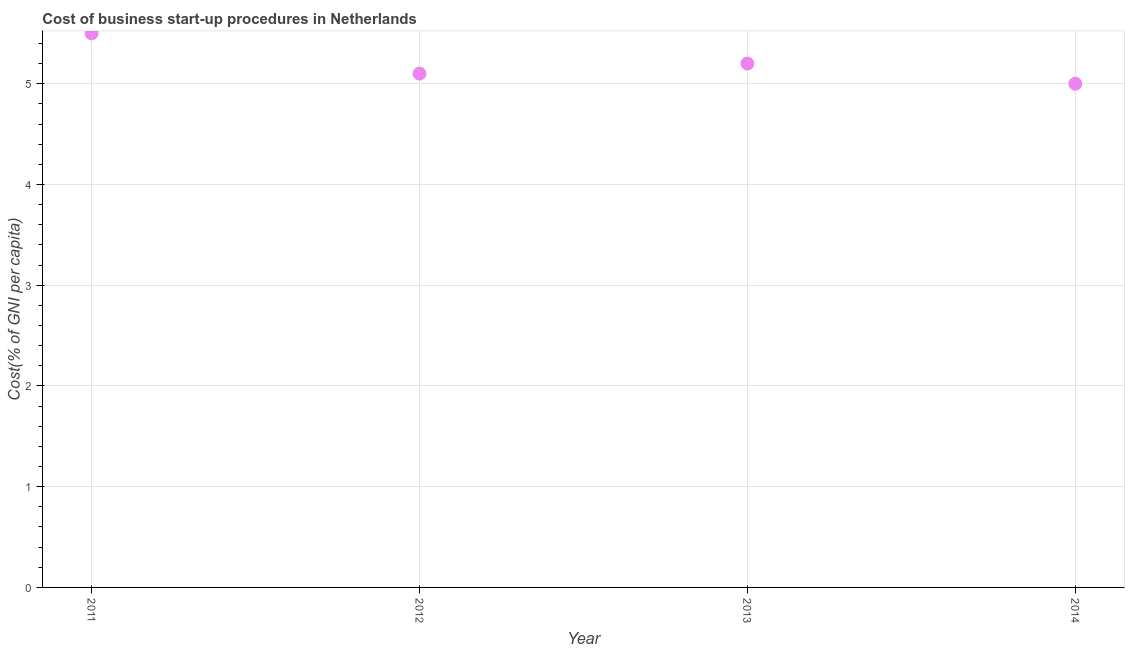What is the cost of business startup procedures in 2014?
Make the answer very short. 5. Across all years, what is the maximum cost of business startup procedures?
Offer a terse response. 5.5. Across all years, what is the minimum cost of business startup procedures?
Provide a succinct answer. 5. In which year was the cost of business startup procedures maximum?
Keep it short and to the point. 2011. In which year was the cost of business startup procedures minimum?
Offer a very short reply. 2014. What is the sum of the cost of business startup procedures?
Your answer should be compact. 20.8. What is the difference between the cost of business startup procedures in 2012 and 2013?
Give a very brief answer. -0.1. What is the median cost of business startup procedures?
Make the answer very short. 5.15. In how many years, is the cost of business startup procedures greater than 3.4 %?
Your answer should be compact. 4. What is the ratio of the cost of business startup procedures in 2011 to that in 2014?
Keep it short and to the point. 1.1. What is the difference between the highest and the second highest cost of business startup procedures?
Offer a terse response. 0.3. What is the difference between two consecutive major ticks on the Y-axis?
Offer a terse response. 1. Does the graph contain any zero values?
Offer a very short reply. No. Does the graph contain grids?
Make the answer very short. Yes. What is the title of the graph?
Your answer should be very brief. Cost of business start-up procedures in Netherlands. What is the label or title of the X-axis?
Your response must be concise. Year. What is the label or title of the Y-axis?
Provide a short and direct response. Cost(% of GNI per capita). What is the Cost(% of GNI per capita) in 2011?
Offer a terse response. 5.5. What is the Cost(% of GNI per capita) in 2012?
Offer a very short reply. 5.1. What is the Cost(% of GNI per capita) in 2013?
Your response must be concise. 5.2. What is the difference between the Cost(% of GNI per capita) in 2011 and 2012?
Give a very brief answer. 0.4. What is the difference between the Cost(% of GNI per capita) in 2011 and 2013?
Make the answer very short. 0.3. What is the difference between the Cost(% of GNI per capita) in 2011 and 2014?
Your answer should be compact. 0.5. What is the ratio of the Cost(% of GNI per capita) in 2011 to that in 2012?
Make the answer very short. 1.08. What is the ratio of the Cost(% of GNI per capita) in 2011 to that in 2013?
Your answer should be very brief. 1.06. 